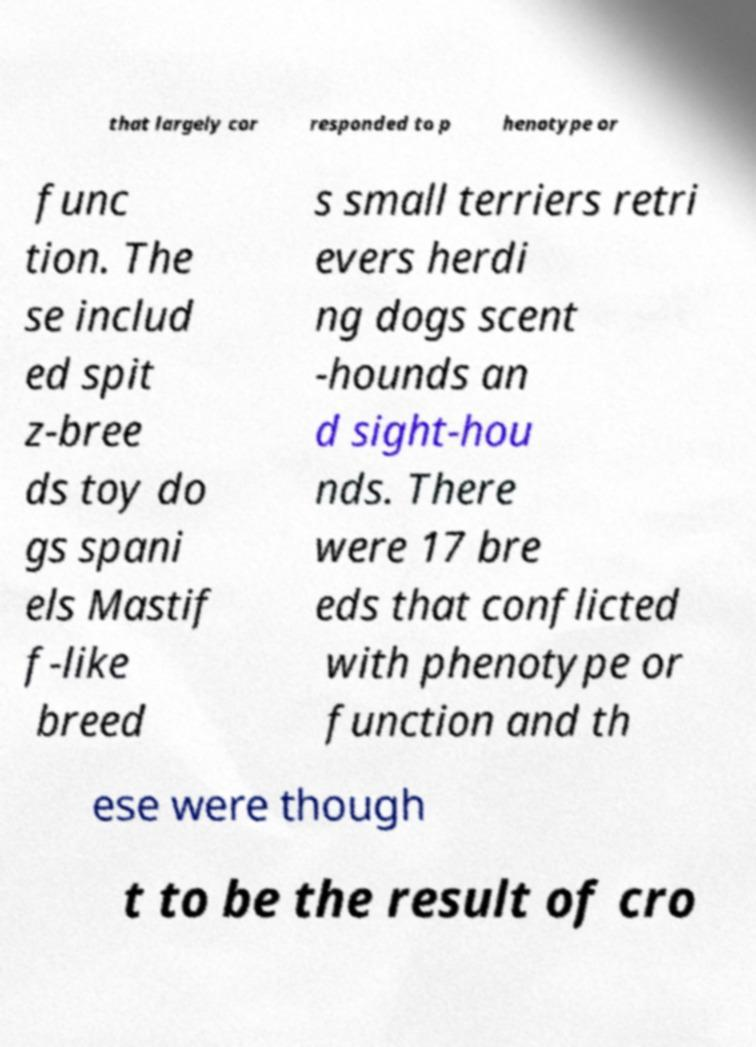Can you read and provide the text displayed in the image?This photo seems to have some interesting text. Can you extract and type it out for me? that largely cor responded to p henotype or func tion. The se includ ed spit z-bree ds toy do gs spani els Mastif f-like breed s small terriers retri evers herdi ng dogs scent -hounds an d sight-hou nds. There were 17 bre eds that conflicted with phenotype or function and th ese were though t to be the result of cro 